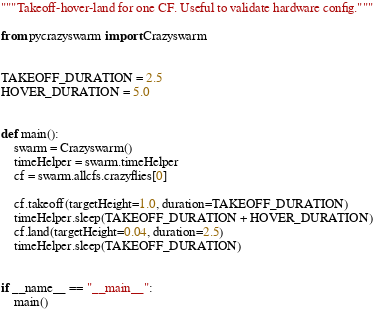Convert code to text. <code><loc_0><loc_0><loc_500><loc_500><_Python_>"""Takeoff-hover-land for one CF. Useful to validate hardware config."""

from pycrazyswarm import Crazyswarm


TAKEOFF_DURATION = 2.5
HOVER_DURATION = 5.0


def main():
    swarm = Crazyswarm()
    timeHelper = swarm.timeHelper
    cf = swarm.allcfs.crazyflies[0]

    cf.takeoff(targetHeight=1.0, duration=TAKEOFF_DURATION)
    timeHelper.sleep(TAKEOFF_DURATION + HOVER_DURATION)
    cf.land(targetHeight=0.04, duration=2.5)
    timeHelper.sleep(TAKEOFF_DURATION)


if __name__ == "__main__":
    main()
</code> 